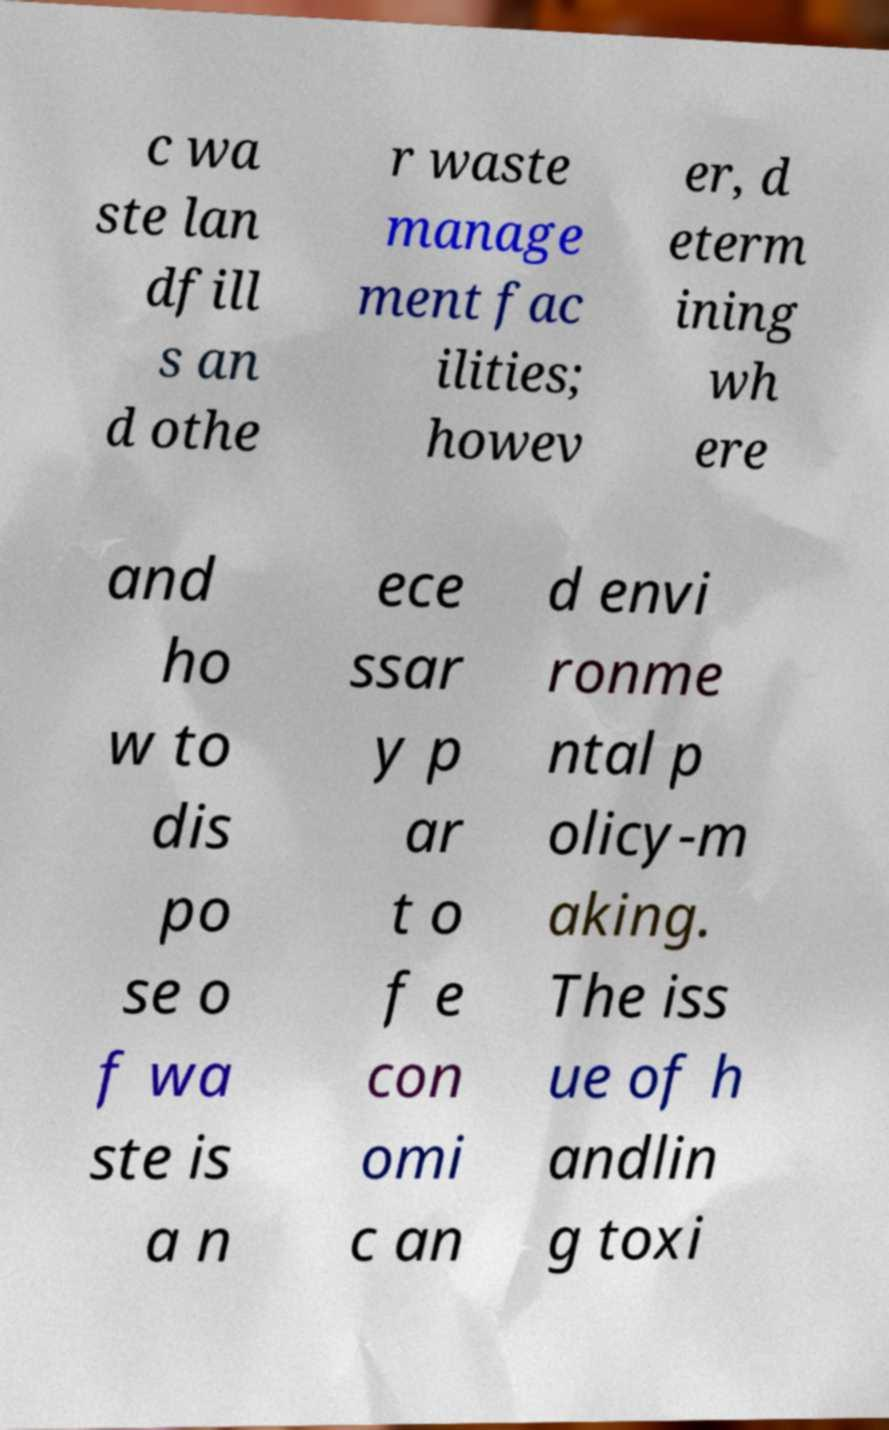For documentation purposes, I need the text within this image transcribed. Could you provide that? c wa ste lan dfill s an d othe r waste manage ment fac ilities; howev er, d eterm ining wh ere and ho w to dis po se o f wa ste is a n ece ssar y p ar t o f e con omi c an d envi ronme ntal p olicy-m aking. The iss ue of h andlin g toxi 